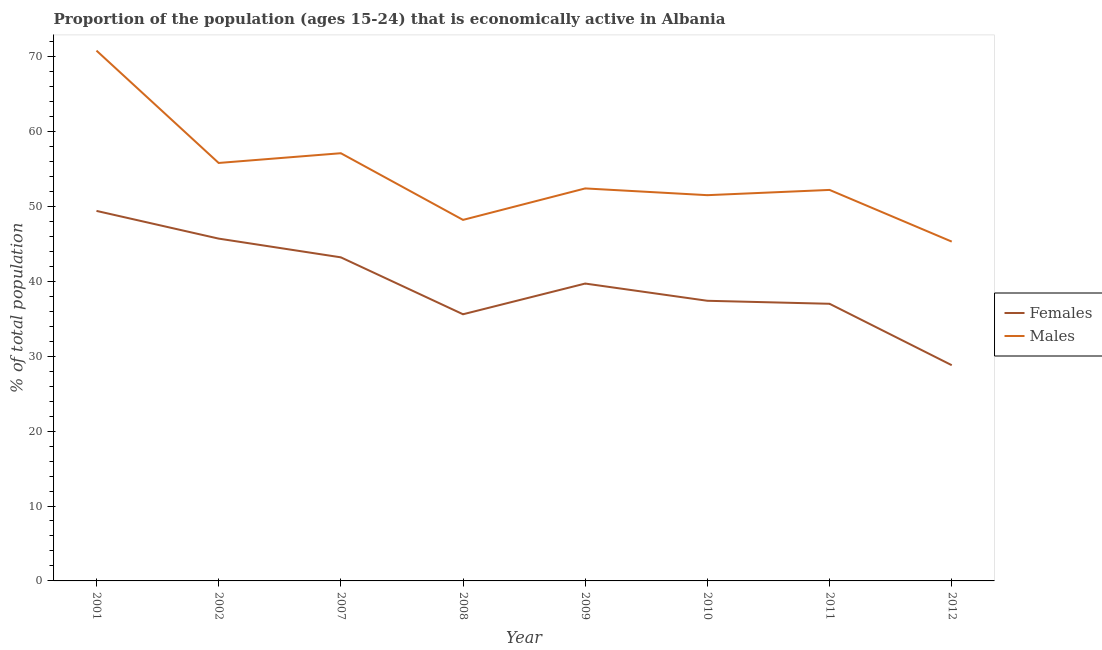How many different coloured lines are there?
Make the answer very short. 2. Is the number of lines equal to the number of legend labels?
Offer a terse response. Yes. What is the percentage of economically active male population in 2008?
Give a very brief answer. 48.2. Across all years, what is the maximum percentage of economically active female population?
Your response must be concise. 49.4. Across all years, what is the minimum percentage of economically active female population?
Ensure brevity in your answer.  28.8. In which year was the percentage of economically active male population maximum?
Keep it short and to the point. 2001. What is the total percentage of economically active female population in the graph?
Keep it short and to the point. 316.8. What is the difference between the percentage of economically active male population in 2001 and that in 2007?
Keep it short and to the point. 13.7. What is the difference between the percentage of economically active female population in 2009 and the percentage of economically active male population in 2001?
Make the answer very short. -31.1. What is the average percentage of economically active male population per year?
Your response must be concise. 54.16. In the year 2010, what is the difference between the percentage of economically active female population and percentage of economically active male population?
Offer a very short reply. -14.1. What is the ratio of the percentage of economically active male population in 2011 to that in 2012?
Provide a short and direct response. 1.15. Is the percentage of economically active male population in 2007 less than that in 2010?
Ensure brevity in your answer.  No. Is the difference between the percentage of economically active female population in 2010 and 2012 greater than the difference between the percentage of economically active male population in 2010 and 2012?
Ensure brevity in your answer.  Yes. What is the difference between the highest and the second highest percentage of economically active female population?
Make the answer very short. 3.7. What is the difference between the highest and the lowest percentage of economically active female population?
Make the answer very short. 20.6. In how many years, is the percentage of economically active female population greater than the average percentage of economically active female population taken over all years?
Keep it short and to the point. 4. Is the percentage of economically active male population strictly greater than the percentage of economically active female population over the years?
Offer a terse response. Yes. How many lines are there?
Your response must be concise. 2. How many years are there in the graph?
Provide a short and direct response. 8. What is the difference between two consecutive major ticks on the Y-axis?
Offer a terse response. 10. Does the graph contain any zero values?
Give a very brief answer. No. How are the legend labels stacked?
Offer a terse response. Vertical. What is the title of the graph?
Give a very brief answer. Proportion of the population (ages 15-24) that is economically active in Albania. What is the label or title of the Y-axis?
Your answer should be compact. % of total population. What is the % of total population of Females in 2001?
Provide a short and direct response. 49.4. What is the % of total population in Males in 2001?
Give a very brief answer. 70.8. What is the % of total population in Females in 2002?
Your answer should be very brief. 45.7. What is the % of total population in Males in 2002?
Provide a succinct answer. 55.8. What is the % of total population in Females in 2007?
Keep it short and to the point. 43.2. What is the % of total population of Males in 2007?
Provide a short and direct response. 57.1. What is the % of total population of Females in 2008?
Provide a short and direct response. 35.6. What is the % of total population in Males in 2008?
Your answer should be very brief. 48.2. What is the % of total population in Females in 2009?
Your response must be concise. 39.7. What is the % of total population of Males in 2009?
Provide a succinct answer. 52.4. What is the % of total population in Females in 2010?
Your answer should be very brief. 37.4. What is the % of total population in Males in 2010?
Your answer should be very brief. 51.5. What is the % of total population in Females in 2011?
Ensure brevity in your answer.  37. What is the % of total population in Males in 2011?
Offer a terse response. 52.2. What is the % of total population of Females in 2012?
Provide a short and direct response. 28.8. What is the % of total population in Males in 2012?
Provide a short and direct response. 45.3. Across all years, what is the maximum % of total population in Females?
Offer a terse response. 49.4. Across all years, what is the maximum % of total population in Males?
Ensure brevity in your answer.  70.8. Across all years, what is the minimum % of total population in Females?
Your response must be concise. 28.8. Across all years, what is the minimum % of total population of Males?
Give a very brief answer. 45.3. What is the total % of total population of Females in the graph?
Ensure brevity in your answer.  316.8. What is the total % of total population of Males in the graph?
Offer a very short reply. 433.3. What is the difference between the % of total population of Females in 2001 and that in 2002?
Your answer should be very brief. 3.7. What is the difference between the % of total population in Females in 2001 and that in 2007?
Offer a terse response. 6.2. What is the difference between the % of total population in Males in 2001 and that in 2008?
Ensure brevity in your answer.  22.6. What is the difference between the % of total population of Males in 2001 and that in 2009?
Provide a short and direct response. 18.4. What is the difference between the % of total population of Males in 2001 and that in 2010?
Ensure brevity in your answer.  19.3. What is the difference between the % of total population in Females in 2001 and that in 2011?
Your response must be concise. 12.4. What is the difference between the % of total population in Females in 2001 and that in 2012?
Offer a very short reply. 20.6. What is the difference between the % of total population in Males in 2001 and that in 2012?
Ensure brevity in your answer.  25.5. What is the difference between the % of total population of Males in 2002 and that in 2008?
Provide a succinct answer. 7.6. What is the difference between the % of total population of Males in 2002 and that in 2009?
Your answer should be compact. 3.4. What is the difference between the % of total population of Males in 2002 and that in 2010?
Ensure brevity in your answer.  4.3. What is the difference between the % of total population in Females in 2002 and that in 2011?
Your answer should be compact. 8.7. What is the difference between the % of total population in Males in 2002 and that in 2011?
Offer a terse response. 3.6. What is the difference between the % of total population in Females in 2002 and that in 2012?
Your response must be concise. 16.9. What is the difference between the % of total population of Males in 2002 and that in 2012?
Provide a short and direct response. 10.5. What is the difference between the % of total population in Females in 2007 and that in 2008?
Offer a very short reply. 7.6. What is the difference between the % of total population of Females in 2007 and that in 2009?
Keep it short and to the point. 3.5. What is the difference between the % of total population in Males in 2007 and that in 2009?
Give a very brief answer. 4.7. What is the difference between the % of total population of Females in 2007 and that in 2010?
Make the answer very short. 5.8. What is the difference between the % of total population in Males in 2007 and that in 2011?
Offer a very short reply. 4.9. What is the difference between the % of total population in Females in 2008 and that in 2009?
Your response must be concise. -4.1. What is the difference between the % of total population of Males in 2008 and that in 2009?
Make the answer very short. -4.2. What is the difference between the % of total population in Females in 2008 and that in 2012?
Your response must be concise. 6.8. What is the difference between the % of total population of Males in 2008 and that in 2012?
Provide a succinct answer. 2.9. What is the difference between the % of total population in Females in 2009 and that in 2010?
Offer a terse response. 2.3. What is the difference between the % of total population of Males in 2009 and that in 2011?
Offer a terse response. 0.2. What is the difference between the % of total population in Females in 2009 and that in 2012?
Keep it short and to the point. 10.9. What is the difference between the % of total population in Females in 2010 and that in 2012?
Offer a very short reply. 8.6. What is the difference between the % of total population of Males in 2010 and that in 2012?
Your answer should be compact. 6.2. What is the difference between the % of total population of Males in 2011 and that in 2012?
Provide a short and direct response. 6.9. What is the difference between the % of total population of Females in 2001 and the % of total population of Males in 2009?
Offer a very short reply. -3. What is the difference between the % of total population in Females in 2001 and the % of total population in Males in 2010?
Your answer should be very brief. -2.1. What is the difference between the % of total population of Females in 2001 and the % of total population of Males in 2012?
Make the answer very short. 4.1. What is the difference between the % of total population of Females in 2002 and the % of total population of Males in 2007?
Offer a terse response. -11.4. What is the difference between the % of total population of Females in 2002 and the % of total population of Males in 2009?
Offer a very short reply. -6.7. What is the difference between the % of total population in Females in 2002 and the % of total population in Males in 2010?
Ensure brevity in your answer.  -5.8. What is the difference between the % of total population of Females in 2002 and the % of total population of Males in 2011?
Your answer should be very brief. -6.5. What is the difference between the % of total population of Females in 2002 and the % of total population of Males in 2012?
Make the answer very short. 0.4. What is the difference between the % of total population in Females in 2007 and the % of total population in Males in 2009?
Keep it short and to the point. -9.2. What is the difference between the % of total population in Females in 2007 and the % of total population in Males in 2011?
Offer a very short reply. -9. What is the difference between the % of total population in Females in 2007 and the % of total population in Males in 2012?
Keep it short and to the point. -2.1. What is the difference between the % of total population in Females in 2008 and the % of total population in Males in 2009?
Make the answer very short. -16.8. What is the difference between the % of total population in Females in 2008 and the % of total population in Males in 2010?
Give a very brief answer. -15.9. What is the difference between the % of total population of Females in 2008 and the % of total population of Males in 2011?
Your answer should be very brief. -16.6. What is the difference between the % of total population of Females in 2008 and the % of total population of Males in 2012?
Offer a terse response. -9.7. What is the difference between the % of total population in Females in 2009 and the % of total population in Males in 2010?
Offer a terse response. -11.8. What is the difference between the % of total population of Females in 2009 and the % of total population of Males in 2012?
Offer a terse response. -5.6. What is the difference between the % of total population of Females in 2010 and the % of total population of Males in 2011?
Your answer should be very brief. -14.8. What is the difference between the % of total population of Females in 2010 and the % of total population of Males in 2012?
Make the answer very short. -7.9. What is the difference between the % of total population of Females in 2011 and the % of total population of Males in 2012?
Offer a very short reply. -8.3. What is the average % of total population in Females per year?
Provide a short and direct response. 39.6. What is the average % of total population of Males per year?
Your answer should be compact. 54.16. In the year 2001, what is the difference between the % of total population of Females and % of total population of Males?
Provide a succinct answer. -21.4. In the year 2010, what is the difference between the % of total population in Females and % of total population in Males?
Provide a short and direct response. -14.1. In the year 2011, what is the difference between the % of total population of Females and % of total population of Males?
Your answer should be compact. -15.2. In the year 2012, what is the difference between the % of total population in Females and % of total population in Males?
Offer a terse response. -16.5. What is the ratio of the % of total population in Females in 2001 to that in 2002?
Give a very brief answer. 1.08. What is the ratio of the % of total population in Males in 2001 to that in 2002?
Keep it short and to the point. 1.27. What is the ratio of the % of total population in Females in 2001 to that in 2007?
Make the answer very short. 1.14. What is the ratio of the % of total population of Males in 2001 to that in 2007?
Keep it short and to the point. 1.24. What is the ratio of the % of total population of Females in 2001 to that in 2008?
Offer a very short reply. 1.39. What is the ratio of the % of total population in Males in 2001 to that in 2008?
Provide a short and direct response. 1.47. What is the ratio of the % of total population of Females in 2001 to that in 2009?
Your answer should be very brief. 1.24. What is the ratio of the % of total population of Males in 2001 to that in 2009?
Your answer should be very brief. 1.35. What is the ratio of the % of total population of Females in 2001 to that in 2010?
Your answer should be very brief. 1.32. What is the ratio of the % of total population of Males in 2001 to that in 2010?
Your answer should be very brief. 1.37. What is the ratio of the % of total population in Females in 2001 to that in 2011?
Provide a short and direct response. 1.34. What is the ratio of the % of total population of Males in 2001 to that in 2011?
Your answer should be very brief. 1.36. What is the ratio of the % of total population of Females in 2001 to that in 2012?
Offer a very short reply. 1.72. What is the ratio of the % of total population in Males in 2001 to that in 2012?
Ensure brevity in your answer.  1.56. What is the ratio of the % of total population in Females in 2002 to that in 2007?
Keep it short and to the point. 1.06. What is the ratio of the % of total population in Males in 2002 to that in 2007?
Provide a short and direct response. 0.98. What is the ratio of the % of total population of Females in 2002 to that in 2008?
Ensure brevity in your answer.  1.28. What is the ratio of the % of total population in Males in 2002 to that in 2008?
Provide a succinct answer. 1.16. What is the ratio of the % of total population of Females in 2002 to that in 2009?
Provide a succinct answer. 1.15. What is the ratio of the % of total population of Males in 2002 to that in 2009?
Offer a very short reply. 1.06. What is the ratio of the % of total population of Females in 2002 to that in 2010?
Provide a succinct answer. 1.22. What is the ratio of the % of total population of Males in 2002 to that in 2010?
Your response must be concise. 1.08. What is the ratio of the % of total population of Females in 2002 to that in 2011?
Provide a succinct answer. 1.24. What is the ratio of the % of total population of Males in 2002 to that in 2011?
Offer a very short reply. 1.07. What is the ratio of the % of total population of Females in 2002 to that in 2012?
Keep it short and to the point. 1.59. What is the ratio of the % of total population of Males in 2002 to that in 2012?
Your response must be concise. 1.23. What is the ratio of the % of total population in Females in 2007 to that in 2008?
Your answer should be very brief. 1.21. What is the ratio of the % of total population in Males in 2007 to that in 2008?
Give a very brief answer. 1.18. What is the ratio of the % of total population in Females in 2007 to that in 2009?
Offer a terse response. 1.09. What is the ratio of the % of total population of Males in 2007 to that in 2009?
Provide a short and direct response. 1.09. What is the ratio of the % of total population of Females in 2007 to that in 2010?
Keep it short and to the point. 1.16. What is the ratio of the % of total population in Males in 2007 to that in 2010?
Ensure brevity in your answer.  1.11. What is the ratio of the % of total population of Females in 2007 to that in 2011?
Your response must be concise. 1.17. What is the ratio of the % of total population in Males in 2007 to that in 2011?
Ensure brevity in your answer.  1.09. What is the ratio of the % of total population of Males in 2007 to that in 2012?
Ensure brevity in your answer.  1.26. What is the ratio of the % of total population in Females in 2008 to that in 2009?
Provide a succinct answer. 0.9. What is the ratio of the % of total population in Males in 2008 to that in 2009?
Your answer should be very brief. 0.92. What is the ratio of the % of total population of Females in 2008 to that in 2010?
Ensure brevity in your answer.  0.95. What is the ratio of the % of total population of Males in 2008 to that in 2010?
Ensure brevity in your answer.  0.94. What is the ratio of the % of total population of Females in 2008 to that in 2011?
Offer a very short reply. 0.96. What is the ratio of the % of total population of Males in 2008 to that in 2011?
Ensure brevity in your answer.  0.92. What is the ratio of the % of total population of Females in 2008 to that in 2012?
Provide a succinct answer. 1.24. What is the ratio of the % of total population of Males in 2008 to that in 2012?
Keep it short and to the point. 1.06. What is the ratio of the % of total population in Females in 2009 to that in 2010?
Offer a very short reply. 1.06. What is the ratio of the % of total population in Males in 2009 to that in 2010?
Provide a short and direct response. 1.02. What is the ratio of the % of total population in Females in 2009 to that in 2011?
Provide a succinct answer. 1.07. What is the ratio of the % of total population of Females in 2009 to that in 2012?
Give a very brief answer. 1.38. What is the ratio of the % of total population in Males in 2009 to that in 2012?
Your answer should be compact. 1.16. What is the ratio of the % of total population in Females in 2010 to that in 2011?
Ensure brevity in your answer.  1.01. What is the ratio of the % of total population in Males in 2010 to that in 2011?
Offer a very short reply. 0.99. What is the ratio of the % of total population of Females in 2010 to that in 2012?
Provide a short and direct response. 1.3. What is the ratio of the % of total population in Males in 2010 to that in 2012?
Make the answer very short. 1.14. What is the ratio of the % of total population of Females in 2011 to that in 2012?
Your answer should be compact. 1.28. What is the ratio of the % of total population in Males in 2011 to that in 2012?
Provide a succinct answer. 1.15. What is the difference between the highest and the second highest % of total population in Females?
Keep it short and to the point. 3.7. What is the difference between the highest and the lowest % of total population of Females?
Offer a very short reply. 20.6. 